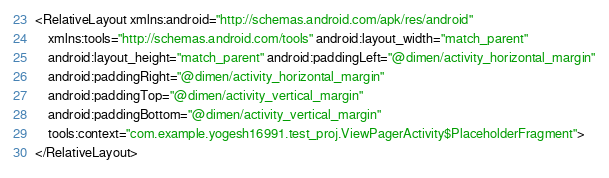Convert code to text. <code><loc_0><loc_0><loc_500><loc_500><_XML_><RelativeLayout xmlns:android="http://schemas.android.com/apk/res/android"
    xmlns:tools="http://schemas.android.com/tools" android:layout_width="match_parent"
    android:layout_height="match_parent" android:paddingLeft="@dimen/activity_horizontal_margin"
    android:paddingRight="@dimen/activity_horizontal_margin"
    android:paddingTop="@dimen/activity_vertical_margin"
    android:paddingBottom="@dimen/activity_vertical_margin"
    tools:context="com.example.yogesh16991.test_proj.ViewPagerActivity$PlaceholderFragment">
</RelativeLayout>
</code> 